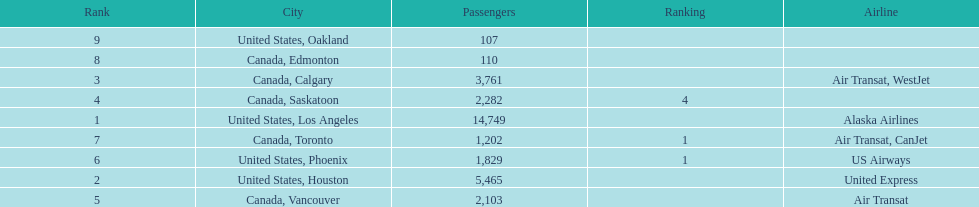The least number of passengers came from which city United States, Oakland. 